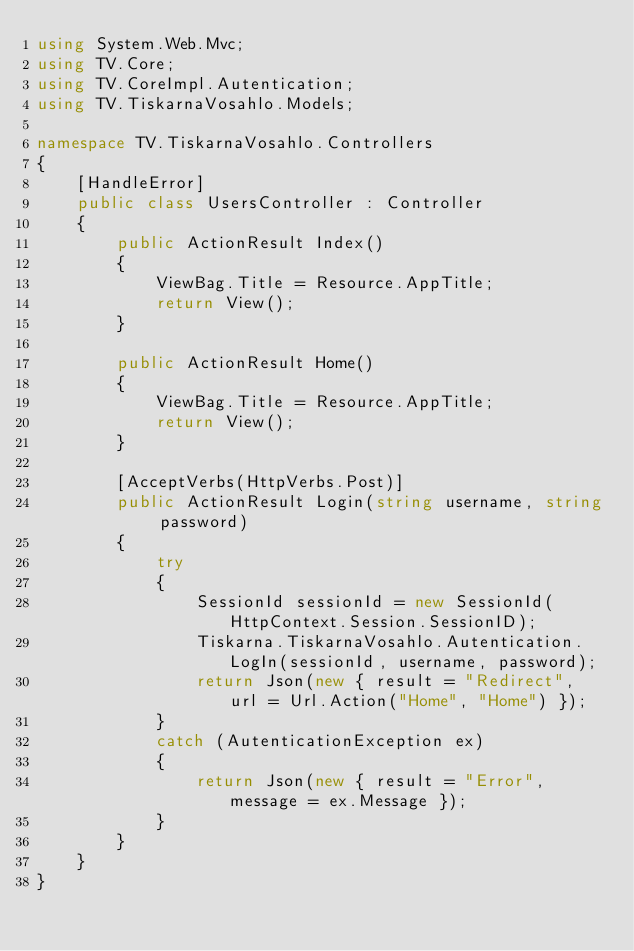Convert code to text. <code><loc_0><loc_0><loc_500><loc_500><_C#_>using System.Web.Mvc;
using TV.Core;
using TV.CoreImpl.Autentication;
using TV.TiskarnaVosahlo.Models;

namespace TV.TiskarnaVosahlo.Controllers
{
    [HandleError]
    public class UsersController : Controller
    {
        public ActionResult Index()
        {
            ViewBag.Title = Resource.AppTitle;
            return View();
        }

        public ActionResult Home()
        {
            ViewBag.Title = Resource.AppTitle;
            return View();
        }

        [AcceptVerbs(HttpVerbs.Post)]
        public ActionResult Login(string username, string password)
        {
            try
            {
                SessionId sessionId = new SessionId(HttpContext.Session.SessionID);
                Tiskarna.TiskarnaVosahlo.Autentication.LogIn(sessionId, username, password);
                return Json(new { result = "Redirect", url = Url.Action("Home", "Home") });
            }
            catch (AutenticationException ex)
            {
                return Json(new { result = "Error", message = ex.Message });
            }
        }
    }
}</code> 